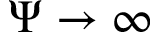Convert formula to latex. <formula><loc_0><loc_0><loc_500><loc_500>\Psi \rightarrow \infty</formula> 